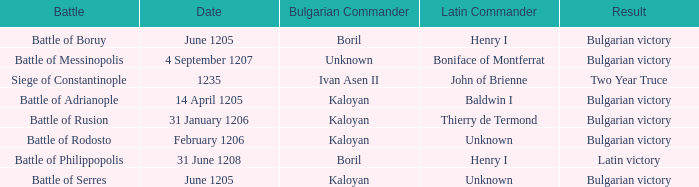Who is the Latin Commander of the Siege of Constantinople? John of Brienne. 